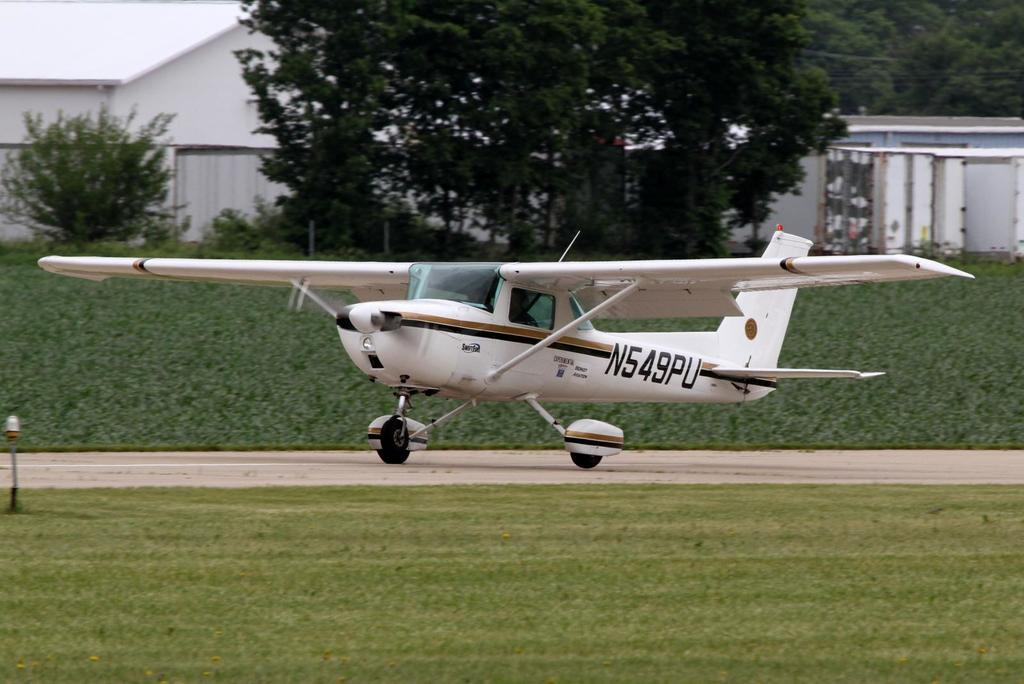<image>
Give a short and clear explanation of the subsequent image. A small white plane is on the ground with SWIFTFUEL EXPERIMENTAL BOUNTY AVIATION N549PU in it. 